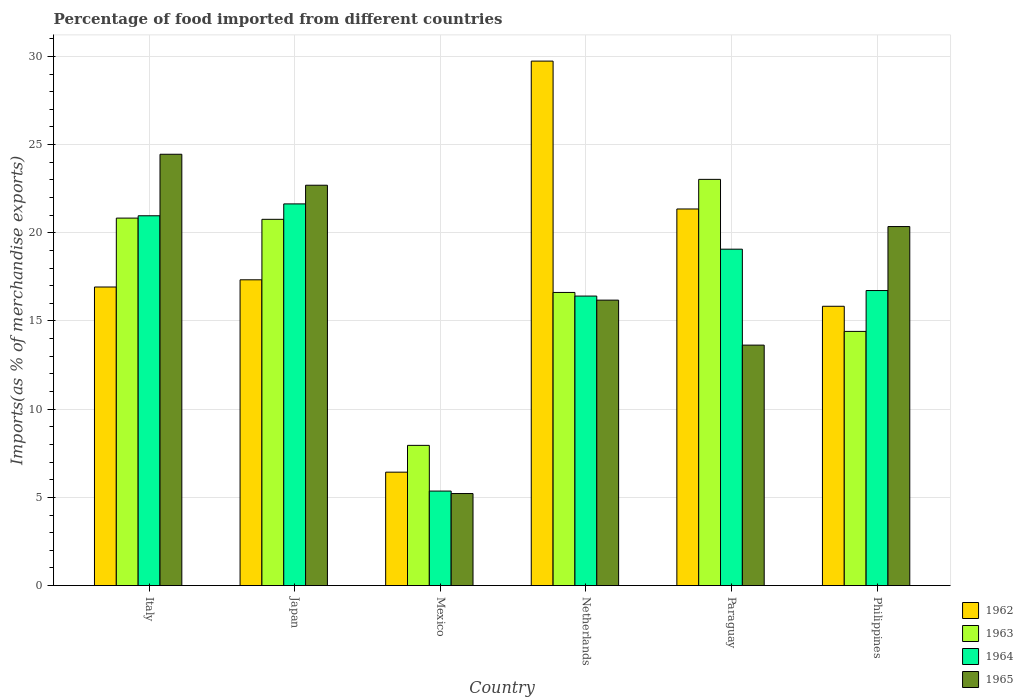How many different coloured bars are there?
Your answer should be very brief. 4. Are the number of bars per tick equal to the number of legend labels?
Make the answer very short. Yes. How many bars are there on the 6th tick from the right?
Keep it short and to the point. 4. What is the percentage of imports to different countries in 1962 in Italy?
Your answer should be compact. 16.93. Across all countries, what is the maximum percentage of imports to different countries in 1962?
Give a very brief answer. 29.73. Across all countries, what is the minimum percentage of imports to different countries in 1965?
Your answer should be compact. 5.22. In which country was the percentage of imports to different countries in 1963 minimum?
Your answer should be very brief. Mexico. What is the total percentage of imports to different countries in 1963 in the graph?
Keep it short and to the point. 103.6. What is the difference between the percentage of imports to different countries in 1965 in Mexico and that in Paraguay?
Provide a short and direct response. -8.42. What is the difference between the percentage of imports to different countries in 1963 in Mexico and the percentage of imports to different countries in 1964 in Philippines?
Make the answer very short. -8.78. What is the average percentage of imports to different countries in 1963 per country?
Ensure brevity in your answer.  17.27. What is the difference between the percentage of imports to different countries of/in 1963 and percentage of imports to different countries of/in 1965 in Italy?
Offer a terse response. -3.62. In how many countries, is the percentage of imports to different countries in 1964 greater than 3 %?
Give a very brief answer. 6. What is the ratio of the percentage of imports to different countries in 1962 in Mexico to that in Philippines?
Keep it short and to the point. 0.41. Is the difference between the percentage of imports to different countries in 1963 in Japan and Mexico greater than the difference between the percentage of imports to different countries in 1965 in Japan and Mexico?
Your answer should be very brief. No. What is the difference between the highest and the second highest percentage of imports to different countries in 1964?
Your answer should be compact. -1.89. What is the difference between the highest and the lowest percentage of imports to different countries in 1963?
Make the answer very short. 15.08. Is it the case that in every country, the sum of the percentage of imports to different countries in 1965 and percentage of imports to different countries in 1962 is greater than the sum of percentage of imports to different countries in 1963 and percentage of imports to different countries in 1964?
Offer a very short reply. No. What does the 4th bar from the left in Italy represents?
Ensure brevity in your answer.  1965. What does the 1st bar from the right in Philippines represents?
Keep it short and to the point. 1965. How many bars are there?
Provide a short and direct response. 24. Are the values on the major ticks of Y-axis written in scientific E-notation?
Provide a short and direct response. No. Does the graph contain grids?
Offer a very short reply. Yes. Where does the legend appear in the graph?
Keep it short and to the point. Bottom right. How many legend labels are there?
Keep it short and to the point. 4. What is the title of the graph?
Make the answer very short. Percentage of food imported from different countries. What is the label or title of the Y-axis?
Your answer should be compact. Imports(as % of merchandise exports). What is the Imports(as % of merchandise exports) of 1962 in Italy?
Provide a short and direct response. 16.93. What is the Imports(as % of merchandise exports) in 1963 in Italy?
Ensure brevity in your answer.  20.83. What is the Imports(as % of merchandise exports) of 1964 in Italy?
Offer a very short reply. 20.97. What is the Imports(as % of merchandise exports) in 1965 in Italy?
Give a very brief answer. 24.45. What is the Imports(as % of merchandise exports) in 1962 in Japan?
Your response must be concise. 17.34. What is the Imports(as % of merchandise exports) in 1963 in Japan?
Offer a terse response. 20.76. What is the Imports(as % of merchandise exports) in 1964 in Japan?
Offer a terse response. 21.64. What is the Imports(as % of merchandise exports) of 1965 in Japan?
Provide a short and direct response. 22.7. What is the Imports(as % of merchandise exports) of 1962 in Mexico?
Offer a terse response. 6.43. What is the Imports(as % of merchandise exports) of 1963 in Mexico?
Make the answer very short. 7.95. What is the Imports(as % of merchandise exports) in 1964 in Mexico?
Ensure brevity in your answer.  5.36. What is the Imports(as % of merchandise exports) of 1965 in Mexico?
Your answer should be very brief. 5.22. What is the Imports(as % of merchandise exports) of 1962 in Netherlands?
Offer a very short reply. 29.73. What is the Imports(as % of merchandise exports) in 1963 in Netherlands?
Provide a short and direct response. 16.62. What is the Imports(as % of merchandise exports) of 1964 in Netherlands?
Your answer should be very brief. 16.41. What is the Imports(as % of merchandise exports) in 1965 in Netherlands?
Offer a very short reply. 16.18. What is the Imports(as % of merchandise exports) in 1962 in Paraguay?
Offer a very short reply. 21.35. What is the Imports(as % of merchandise exports) in 1963 in Paraguay?
Provide a short and direct response. 23.03. What is the Imports(as % of merchandise exports) in 1964 in Paraguay?
Give a very brief answer. 19.07. What is the Imports(as % of merchandise exports) in 1965 in Paraguay?
Offer a terse response. 13.63. What is the Imports(as % of merchandise exports) in 1962 in Philippines?
Your answer should be compact. 15.83. What is the Imports(as % of merchandise exports) in 1963 in Philippines?
Make the answer very short. 14.41. What is the Imports(as % of merchandise exports) in 1964 in Philippines?
Make the answer very short. 16.73. What is the Imports(as % of merchandise exports) in 1965 in Philippines?
Offer a terse response. 20.35. Across all countries, what is the maximum Imports(as % of merchandise exports) of 1962?
Your response must be concise. 29.73. Across all countries, what is the maximum Imports(as % of merchandise exports) in 1963?
Provide a short and direct response. 23.03. Across all countries, what is the maximum Imports(as % of merchandise exports) in 1964?
Make the answer very short. 21.64. Across all countries, what is the maximum Imports(as % of merchandise exports) in 1965?
Give a very brief answer. 24.45. Across all countries, what is the minimum Imports(as % of merchandise exports) of 1962?
Your response must be concise. 6.43. Across all countries, what is the minimum Imports(as % of merchandise exports) of 1963?
Your answer should be very brief. 7.95. Across all countries, what is the minimum Imports(as % of merchandise exports) in 1964?
Offer a very short reply. 5.36. Across all countries, what is the minimum Imports(as % of merchandise exports) of 1965?
Your response must be concise. 5.22. What is the total Imports(as % of merchandise exports) in 1962 in the graph?
Make the answer very short. 107.61. What is the total Imports(as % of merchandise exports) in 1963 in the graph?
Provide a short and direct response. 103.6. What is the total Imports(as % of merchandise exports) in 1964 in the graph?
Provide a succinct answer. 100.17. What is the total Imports(as % of merchandise exports) of 1965 in the graph?
Offer a very short reply. 102.53. What is the difference between the Imports(as % of merchandise exports) of 1962 in Italy and that in Japan?
Offer a terse response. -0.41. What is the difference between the Imports(as % of merchandise exports) of 1963 in Italy and that in Japan?
Keep it short and to the point. 0.07. What is the difference between the Imports(as % of merchandise exports) in 1964 in Italy and that in Japan?
Offer a terse response. -0.67. What is the difference between the Imports(as % of merchandise exports) in 1965 in Italy and that in Japan?
Give a very brief answer. 1.76. What is the difference between the Imports(as % of merchandise exports) of 1962 in Italy and that in Mexico?
Make the answer very short. 10.5. What is the difference between the Imports(as % of merchandise exports) of 1963 in Italy and that in Mexico?
Give a very brief answer. 12.88. What is the difference between the Imports(as % of merchandise exports) in 1964 in Italy and that in Mexico?
Offer a very short reply. 15.61. What is the difference between the Imports(as % of merchandise exports) in 1965 in Italy and that in Mexico?
Ensure brevity in your answer.  19.24. What is the difference between the Imports(as % of merchandise exports) of 1962 in Italy and that in Netherlands?
Your answer should be compact. -12.81. What is the difference between the Imports(as % of merchandise exports) of 1963 in Italy and that in Netherlands?
Offer a terse response. 4.21. What is the difference between the Imports(as % of merchandise exports) of 1964 in Italy and that in Netherlands?
Your response must be concise. 4.55. What is the difference between the Imports(as % of merchandise exports) in 1965 in Italy and that in Netherlands?
Keep it short and to the point. 8.27. What is the difference between the Imports(as % of merchandise exports) of 1962 in Italy and that in Paraguay?
Provide a succinct answer. -4.42. What is the difference between the Imports(as % of merchandise exports) in 1963 in Italy and that in Paraguay?
Your response must be concise. -2.2. What is the difference between the Imports(as % of merchandise exports) of 1964 in Italy and that in Paraguay?
Offer a very short reply. 1.89. What is the difference between the Imports(as % of merchandise exports) in 1965 in Italy and that in Paraguay?
Your answer should be compact. 10.82. What is the difference between the Imports(as % of merchandise exports) in 1962 in Italy and that in Philippines?
Offer a very short reply. 1.09. What is the difference between the Imports(as % of merchandise exports) in 1963 in Italy and that in Philippines?
Provide a succinct answer. 6.42. What is the difference between the Imports(as % of merchandise exports) in 1964 in Italy and that in Philippines?
Make the answer very short. 4.24. What is the difference between the Imports(as % of merchandise exports) in 1965 in Italy and that in Philippines?
Keep it short and to the point. 4.1. What is the difference between the Imports(as % of merchandise exports) of 1962 in Japan and that in Mexico?
Make the answer very short. 10.91. What is the difference between the Imports(as % of merchandise exports) in 1963 in Japan and that in Mexico?
Offer a terse response. 12.82. What is the difference between the Imports(as % of merchandise exports) in 1964 in Japan and that in Mexico?
Make the answer very short. 16.28. What is the difference between the Imports(as % of merchandise exports) in 1965 in Japan and that in Mexico?
Make the answer very short. 17.48. What is the difference between the Imports(as % of merchandise exports) of 1962 in Japan and that in Netherlands?
Provide a short and direct response. -12.4. What is the difference between the Imports(as % of merchandise exports) of 1963 in Japan and that in Netherlands?
Your response must be concise. 4.15. What is the difference between the Imports(as % of merchandise exports) in 1964 in Japan and that in Netherlands?
Keep it short and to the point. 5.23. What is the difference between the Imports(as % of merchandise exports) of 1965 in Japan and that in Netherlands?
Your answer should be very brief. 6.51. What is the difference between the Imports(as % of merchandise exports) of 1962 in Japan and that in Paraguay?
Your answer should be compact. -4.02. What is the difference between the Imports(as % of merchandise exports) of 1963 in Japan and that in Paraguay?
Ensure brevity in your answer.  -2.26. What is the difference between the Imports(as % of merchandise exports) in 1964 in Japan and that in Paraguay?
Your answer should be compact. 2.57. What is the difference between the Imports(as % of merchandise exports) in 1965 in Japan and that in Paraguay?
Keep it short and to the point. 9.06. What is the difference between the Imports(as % of merchandise exports) in 1962 in Japan and that in Philippines?
Provide a short and direct response. 1.5. What is the difference between the Imports(as % of merchandise exports) of 1963 in Japan and that in Philippines?
Offer a terse response. 6.35. What is the difference between the Imports(as % of merchandise exports) in 1964 in Japan and that in Philippines?
Make the answer very short. 4.91. What is the difference between the Imports(as % of merchandise exports) of 1965 in Japan and that in Philippines?
Offer a terse response. 2.34. What is the difference between the Imports(as % of merchandise exports) in 1962 in Mexico and that in Netherlands?
Ensure brevity in your answer.  -23.31. What is the difference between the Imports(as % of merchandise exports) in 1963 in Mexico and that in Netherlands?
Provide a succinct answer. -8.67. What is the difference between the Imports(as % of merchandise exports) in 1964 in Mexico and that in Netherlands?
Your response must be concise. -11.05. What is the difference between the Imports(as % of merchandise exports) in 1965 in Mexico and that in Netherlands?
Your response must be concise. -10.97. What is the difference between the Imports(as % of merchandise exports) of 1962 in Mexico and that in Paraguay?
Your answer should be compact. -14.92. What is the difference between the Imports(as % of merchandise exports) of 1963 in Mexico and that in Paraguay?
Offer a very short reply. -15.08. What is the difference between the Imports(as % of merchandise exports) in 1964 in Mexico and that in Paraguay?
Keep it short and to the point. -13.71. What is the difference between the Imports(as % of merchandise exports) of 1965 in Mexico and that in Paraguay?
Your answer should be very brief. -8.42. What is the difference between the Imports(as % of merchandise exports) in 1962 in Mexico and that in Philippines?
Your response must be concise. -9.41. What is the difference between the Imports(as % of merchandise exports) in 1963 in Mexico and that in Philippines?
Offer a very short reply. -6.46. What is the difference between the Imports(as % of merchandise exports) of 1964 in Mexico and that in Philippines?
Provide a short and direct response. -11.37. What is the difference between the Imports(as % of merchandise exports) in 1965 in Mexico and that in Philippines?
Your answer should be compact. -15.14. What is the difference between the Imports(as % of merchandise exports) of 1962 in Netherlands and that in Paraguay?
Offer a very short reply. 8.38. What is the difference between the Imports(as % of merchandise exports) in 1963 in Netherlands and that in Paraguay?
Your response must be concise. -6.41. What is the difference between the Imports(as % of merchandise exports) of 1964 in Netherlands and that in Paraguay?
Offer a terse response. -2.66. What is the difference between the Imports(as % of merchandise exports) in 1965 in Netherlands and that in Paraguay?
Ensure brevity in your answer.  2.55. What is the difference between the Imports(as % of merchandise exports) of 1962 in Netherlands and that in Philippines?
Keep it short and to the point. 13.9. What is the difference between the Imports(as % of merchandise exports) in 1963 in Netherlands and that in Philippines?
Provide a succinct answer. 2.21. What is the difference between the Imports(as % of merchandise exports) in 1964 in Netherlands and that in Philippines?
Provide a short and direct response. -0.31. What is the difference between the Imports(as % of merchandise exports) of 1965 in Netherlands and that in Philippines?
Make the answer very short. -4.17. What is the difference between the Imports(as % of merchandise exports) in 1962 in Paraguay and that in Philippines?
Ensure brevity in your answer.  5.52. What is the difference between the Imports(as % of merchandise exports) of 1963 in Paraguay and that in Philippines?
Give a very brief answer. 8.62. What is the difference between the Imports(as % of merchandise exports) of 1964 in Paraguay and that in Philippines?
Make the answer very short. 2.35. What is the difference between the Imports(as % of merchandise exports) of 1965 in Paraguay and that in Philippines?
Offer a terse response. -6.72. What is the difference between the Imports(as % of merchandise exports) in 1962 in Italy and the Imports(as % of merchandise exports) in 1963 in Japan?
Your answer should be compact. -3.84. What is the difference between the Imports(as % of merchandise exports) of 1962 in Italy and the Imports(as % of merchandise exports) of 1964 in Japan?
Offer a very short reply. -4.71. What is the difference between the Imports(as % of merchandise exports) in 1962 in Italy and the Imports(as % of merchandise exports) in 1965 in Japan?
Keep it short and to the point. -5.77. What is the difference between the Imports(as % of merchandise exports) in 1963 in Italy and the Imports(as % of merchandise exports) in 1964 in Japan?
Offer a terse response. -0.81. What is the difference between the Imports(as % of merchandise exports) in 1963 in Italy and the Imports(as % of merchandise exports) in 1965 in Japan?
Make the answer very short. -1.86. What is the difference between the Imports(as % of merchandise exports) in 1964 in Italy and the Imports(as % of merchandise exports) in 1965 in Japan?
Give a very brief answer. -1.73. What is the difference between the Imports(as % of merchandise exports) of 1962 in Italy and the Imports(as % of merchandise exports) of 1963 in Mexico?
Provide a succinct answer. 8.98. What is the difference between the Imports(as % of merchandise exports) of 1962 in Italy and the Imports(as % of merchandise exports) of 1964 in Mexico?
Your answer should be very brief. 11.57. What is the difference between the Imports(as % of merchandise exports) of 1962 in Italy and the Imports(as % of merchandise exports) of 1965 in Mexico?
Offer a very short reply. 11.71. What is the difference between the Imports(as % of merchandise exports) of 1963 in Italy and the Imports(as % of merchandise exports) of 1964 in Mexico?
Your answer should be very brief. 15.48. What is the difference between the Imports(as % of merchandise exports) in 1963 in Italy and the Imports(as % of merchandise exports) in 1965 in Mexico?
Your response must be concise. 15.62. What is the difference between the Imports(as % of merchandise exports) of 1964 in Italy and the Imports(as % of merchandise exports) of 1965 in Mexico?
Ensure brevity in your answer.  15.75. What is the difference between the Imports(as % of merchandise exports) of 1962 in Italy and the Imports(as % of merchandise exports) of 1963 in Netherlands?
Provide a succinct answer. 0.31. What is the difference between the Imports(as % of merchandise exports) in 1962 in Italy and the Imports(as % of merchandise exports) in 1964 in Netherlands?
Your answer should be compact. 0.51. What is the difference between the Imports(as % of merchandise exports) in 1962 in Italy and the Imports(as % of merchandise exports) in 1965 in Netherlands?
Offer a terse response. 0.74. What is the difference between the Imports(as % of merchandise exports) in 1963 in Italy and the Imports(as % of merchandise exports) in 1964 in Netherlands?
Offer a very short reply. 4.42. What is the difference between the Imports(as % of merchandise exports) of 1963 in Italy and the Imports(as % of merchandise exports) of 1965 in Netherlands?
Offer a very short reply. 4.65. What is the difference between the Imports(as % of merchandise exports) of 1964 in Italy and the Imports(as % of merchandise exports) of 1965 in Netherlands?
Provide a succinct answer. 4.78. What is the difference between the Imports(as % of merchandise exports) in 1962 in Italy and the Imports(as % of merchandise exports) in 1963 in Paraguay?
Provide a short and direct response. -6.1. What is the difference between the Imports(as % of merchandise exports) in 1962 in Italy and the Imports(as % of merchandise exports) in 1964 in Paraguay?
Offer a terse response. -2.14. What is the difference between the Imports(as % of merchandise exports) of 1962 in Italy and the Imports(as % of merchandise exports) of 1965 in Paraguay?
Provide a short and direct response. 3.29. What is the difference between the Imports(as % of merchandise exports) in 1963 in Italy and the Imports(as % of merchandise exports) in 1964 in Paraguay?
Ensure brevity in your answer.  1.76. What is the difference between the Imports(as % of merchandise exports) in 1963 in Italy and the Imports(as % of merchandise exports) in 1965 in Paraguay?
Your answer should be very brief. 7.2. What is the difference between the Imports(as % of merchandise exports) in 1964 in Italy and the Imports(as % of merchandise exports) in 1965 in Paraguay?
Your answer should be very brief. 7.33. What is the difference between the Imports(as % of merchandise exports) of 1962 in Italy and the Imports(as % of merchandise exports) of 1963 in Philippines?
Give a very brief answer. 2.52. What is the difference between the Imports(as % of merchandise exports) of 1962 in Italy and the Imports(as % of merchandise exports) of 1964 in Philippines?
Keep it short and to the point. 0.2. What is the difference between the Imports(as % of merchandise exports) of 1962 in Italy and the Imports(as % of merchandise exports) of 1965 in Philippines?
Make the answer very short. -3.43. What is the difference between the Imports(as % of merchandise exports) of 1963 in Italy and the Imports(as % of merchandise exports) of 1964 in Philippines?
Offer a terse response. 4.11. What is the difference between the Imports(as % of merchandise exports) of 1963 in Italy and the Imports(as % of merchandise exports) of 1965 in Philippines?
Your answer should be compact. 0.48. What is the difference between the Imports(as % of merchandise exports) in 1964 in Italy and the Imports(as % of merchandise exports) in 1965 in Philippines?
Ensure brevity in your answer.  0.61. What is the difference between the Imports(as % of merchandise exports) of 1962 in Japan and the Imports(as % of merchandise exports) of 1963 in Mexico?
Your answer should be compact. 9.39. What is the difference between the Imports(as % of merchandise exports) in 1962 in Japan and the Imports(as % of merchandise exports) in 1964 in Mexico?
Ensure brevity in your answer.  11.98. What is the difference between the Imports(as % of merchandise exports) of 1962 in Japan and the Imports(as % of merchandise exports) of 1965 in Mexico?
Ensure brevity in your answer.  12.12. What is the difference between the Imports(as % of merchandise exports) in 1963 in Japan and the Imports(as % of merchandise exports) in 1964 in Mexico?
Give a very brief answer. 15.41. What is the difference between the Imports(as % of merchandise exports) of 1963 in Japan and the Imports(as % of merchandise exports) of 1965 in Mexico?
Keep it short and to the point. 15.55. What is the difference between the Imports(as % of merchandise exports) of 1964 in Japan and the Imports(as % of merchandise exports) of 1965 in Mexico?
Provide a short and direct response. 16.42. What is the difference between the Imports(as % of merchandise exports) in 1962 in Japan and the Imports(as % of merchandise exports) in 1963 in Netherlands?
Your answer should be very brief. 0.72. What is the difference between the Imports(as % of merchandise exports) in 1962 in Japan and the Imports(as % of merchandise exports) in 1964 in Netherlands?
Your answer should be compact. 0.92. What is the difference between the Imports(as % of merchandise exports) of 1962 in Japan and the Imports(as % of merchandise exports) of 1965 in Netherlands?
Offer a terse response. 1.15. What is the difference between the Imports(as % of merchandise exports) in 1963 in Japan and the Imports(as % of merchandise exports) in 1964 in Netherlands?
Give a very brief answer. 4.35. What is the difference between the Imports(as % of merchandise exports) of 1963 in Japan and the Imports(as % of merchandise exports) of 1965 in Netherlands?
Offer a very short reply. 4.58. What is the difference between the Imports(as % of merchandise exports) of 1964 in Japan and the Imports(as % of merchandise exports) of 1965 in Netherlands?
Offer a terse response. 5.46. What is the difference between the Imports(as % of merchandise exports) in 1962 in Japan and the Imports(as % of merchandise exports) in 1963 in Paraguay?
Your answer should be compact. -5.69. What is the difference between the Imports(as % of merchandise exports) in 1962 in Japan and the Imports(as % of merchandise exports) in 1964 in Paraguay?
Keep it short and to the point. -1.74. What is the difference between the Imports(as % of merchandise exports) of 1962 in Japan and the Imports(as % of merchandise exports) of 1965 in Paraguay?
Give a very brief answer. 3.7. What is the difference between the Imports(as % of merchandise exports) of 1963 in Japan and the Imports(as % of merchandise exports) of 1964 in Paraguay?
Provide a succinct answer. 1.69. What is the difference between the Imports(as % of merchandise exports) of 1963 in Japan and the Imports(as % of merchandise exports) of 1965 in Paraguay?
Your answer should be compact. 7.13. What is the difference between the Imports(as % of merchandise exports) in 1964 in Japan and the Imports(as % of merchandise exports) in 1965 in Paraguay?
Keep it short and to the point. 8.01. What is the difference between the Imports(as % of merchandise exports) in 1962 in Japan and the Imports(as % of merchandise exports) in 1963 in Philippines?
Give a very brief answer. 2.93. What is the difference between the Imports(as % of merchandise exports) in 1962 in Japan and the Imports(as % of merchandise exports) in 1964 in Philippines?
Provide a short and direct response. 0.61. What is the difference between the Imports(as % of merchandise exports) of 1962 in Japan and the Imports(as % of merchandise exports) of 1965 in Philippines?
Ensure brevity in your answer.  -3.02. What is the difference between the Imports(as % of merchandise exports) in 1963 in Japan and the Imports(as % of merchandise exports) in 1964 in Philippines?
Your answer should be very brief. 4.04. What is the difference between the Imports(as % of merchandise exports) of 1963 in Japan and the Imports(as % of merchandise exports) of 1965 in Philippines?
Provide a succinct answer. 0.41. What is the difference between the Imports(as % of merchandise exports) in 1964 in Japan and the Imports(as % of merchandise exports) in 1965 in Philippines?
Keep it short and to the point. 1.28. What is the difference between the Imports(as % of merchandise exports) of 1962 in Mexico and the Imports(as % of merchandise exports) of 1963 in Netherlands?
Provide a short and direct response. -10.19. What is the difference between the Imports(as % of merchandise exports) of 1962 in Mexico and the Imports(as % of merchandise exports) of 1964 in Netherlands?
Ensure brevity in your answer.  -9.98. What is the difference between the Imports(as % of merchandise exports) in 1962 in Mexico and the Imports(as % of merchandise exports) in 1965 in Netherlands?
Your answer should be very brief. -9.75. What is the difference between the Imports(as % of merchandise exports) of 1963 in Mexico and the Imports(as % of merchandise exports) of 1964 in Netherlands?
Your response must be concise. -8.46. What is the difference between the Imports(as % of merchandise exports) of 1963 in Mexico and the Imports(as % of merchandise exports) of 1965 in Netherlands?
Your answer should be compact. -8.23. What is the difference between the Imports(as % of merchandise exports) in 1964 in Mexico and the Imports(as % of merchandise exports) in 1965 in Netherlands?
Provide a short and direct response. -10.83. What is the difference between the Imports(as % of merchandise exports) in 1962 in Mexico and the Imports(as % of merchandise exports) in 1963 in Paraguay?
Provide a short and direct response. -16.6. What is the difference between the Imports(as % of merchandise exports) in 1962 in Mexico and the Imports(as % of merchandise exports) in 1964 in Paraguay?
Your answer should be compact. -12.64. What is the difference between the Imports(as % of merchandise exports) in 1962 in Mexico and the Imports(as % of merchandise exports) in 1965 in Paraguay?
Your answer should be compact. -7.2. What is the difference between the Imports(as % of merchandise exports) in 1963 in Mexico and the Imports(as % of merchandise exports) in 1964 in Paraguay?
Offer a very short reply. -11.12. What is the difference between the Imports(as % of merchandise exports) in 1963 in Mexico and the Imports(as % of merchandise exports) in 1965 in Paraguay?
Offer a very short reply. -5.68. What is the difference between the Imports(as % of merchandise exports) in 1964 in Mexico and the Imports(as % of merchandise exports) in 1965 in Paraguay?
Make the answer very short. -8.27. What is the difference between the Imports(as % of merchandise exports) of 1962 in Mexico and the Imports(as % of merchandise exports) of 1963 in Philippines?
Provide a short and direct response. -7.98. What is the difference between the Imports(as % of merchandise exports) in 1962 in Mexico and the Imports(as % of merchandise exports) in 1964 in Philippines?
Make the answer very short. -10.3. What is the difference between the Imports(as % of merchandise exports) of 1962 in Mexico and the Imports(as % of merchandise exports) of 1965 in Philippines?
Make the answer very short. -13.93. What is the difference between the Imports(as % of merchandise exports) in 1963 in Mexico and the Imports(as % of merchandise exports) in 1964 in Philippines?
Make the answer very short. -8.78. What is the difference between the Imports(as % of merchandise exports) in 1963 in Mexico and the Imports(as % of merchandise exports) in 1965 in Philippines?
Keep it short and to the point. -12.41. What is the difference between the Imports(as % of merchandise exports) of 1964 in Mexico and the Imports(as % of merchandise exports) of 1965 in Philippines?
Offer a terse response. -15. What is the difference between the Imports(as % of merchandise exports) of 1962 in Netherlands and the Imports(as % of merchandise exports) of 1963 in Paraguay?
Provide a short and direct response. 6.71. What is the difference between the Imports(as % of merchandise exports) in 1962 in Netherlands and the Imports(as % of merchandise exports) in 1964 in Paraguay?
Your answer should be compact. 10.66. What is the difference between the Imports(as % of merchandise exports) of 1962 in Netherlands and the Imports(as % of merchandise exports) of 1965 in Paraguay?
Offer a terse response. 16.1. What is the difference between the Imports(as % of merchandise exports) of 1963 in Netherlands and the Imports(as % of merchandise exports) of 1964 in Paraguay?
Your answer should be compact. -2.45. What is the difference between the Imports(as % of merchandise exports) in 1963 in Netherlands and the Imports(as % of merchandise exports) in 1965 in Paraguay?
Make the answer very short. 2.99. What is the difference between the Imports(as % of merchandise exports) in 1964 in Netherlands and the Imports(as % of merchandise exports) in 1965 in Paraguay?
Make the answer very short. 2.78. What is the difference between the Imports(as % of merchandise exports) of 1962 in Netherlands and the Imports(as % of merchandise exports) of 1963 in Philippines?
Your answer should be very brief. 15.32. What is the difference between the Imports(as % of merchandise exports) of 1962 in Netherlands and the Imports(as % of merchandise exports) of 1964 in Philippines?
Your answer should be compact. 13.01. What is the difference between the Imports(as % of merchandise exports) in 1962 in Netherlands and the Imports(as % of merchandise exports) in 1965 in Philippines?
Give a very brief answer. 9.38. What is the difference between the Imports(as % of merchandise exports) of 1963 in Netherlands and the Imports(as % of merchandise exports) of 1964 in Philippines?
Your response must be concise. -0.11. What is the difference between the Imports(as % of merchandise exports) in 1963 in Netherlands and the Imports(as % of merchandise exports) in 1965 in Philippines?
Provide a short and direct response. -3.74. What is the difference between the Imports(as % of merchandise exports) in 1964 in Netherlands and the Imports(as % of merchandise exports) in 1965 in Philippines?
Keep it short and to the point. -3.94. What is the difference between the Imports(as % of merchandise exports) of 1962 in Paraguay and the Imports(as % of merchandise exports) of 1963 in Philippines?
Make the answer very short. 6.94. What is the difference between the Imports(as % of merchandise exports) of 1962 in Paraguay and the Imports(as % of merchandise exports) of 1964 in Philippines?
Give a very brief answer. 4.62. What is the difference between the Imports(as % of merchandise exports) of 1963 in Paraguay and the Imports(as % of merchandise exports) of 1964 in Philippines?
Provide a short and direct response. 6.3. What is the difference between the Imports(as % of merchandise exports) of 1963 in Paraguay and the Imports(as % of merchandise exports) of 1965 in Philippines?
Make the answer very short. 2.67. What is the difference between the Imports(as % of merchandise exports) in 1964 in Paraguay and the Imports(as % of merchandise exports) in 1965 in Philippines?
Offer a terse response. -1.28. What is the average Imports(as % of merchandise exports) of 1962 per country?
Give a very brief answer. 17.93. What is the average Imports(as % of merchandise exports) of 1963 per country?
Provide a short and direct response. 17.27. What is the average Imports(as % of merchandise exports) in 1964 per country?
Your answer should be very brief. 16.7. What is the average Imports(as % of merchandise exports) in 1965 per country?
Your answer should be compact. 17.09. What is the difference between the Imports(as % of merchandise exports) of 1962 and Imports(as % of merchandise exports) of 1963 in Italy?
Provide a short and direct response. -3.91. What is the difference between the Imports(as % of merchandise exports) of 1962 and Imports(as % of merchandise exports) of 1964 in Italy?
Ensure brevity in your answer.  -4.04. What is the difference between the Imports(as % of merchandise exports) in 1962 and Imports(as % of merchandise exports) in 1965 in Italy?
Offer a terse response. -7.53. What is the difference between the Imports(as % of merchandise exports) in 1963 and Imports(as % of merchandise exports) in 1964 in Italy?
Ensure brevity in your answer.  -0.13. What is the difference between the Imports(as % of merchandise exports) of 1963 and Imports(as % of merchandise exports) of 1965 in Italy?
Provide a short and direct response. -3.62. What is the difference between the Imports(as % of merchandise exports) in 1964 and Imports(as % of merchandise exports) in 1965 in Italy?
Your answer should be compact. -3.49. What is the difference between the Imports(as % of merchandise exports) in 1962 and Imports(as % of merchandise exports) in 1963 in Japan?
Offer a very short reply. -3.43. What is the difference between the Imports(as % of merchandise exports) of 1962 and Imports(as % of merchandise exports) of 1964 in Japan?
Provide a succinct answer. -4.3. What is the difference between the Imports(as % of merchandise exports) of 1962 and Imports(as % of merchandise exports) of 1965 in Japan?
Make the answer very short. -5.36. What is the difference between the Imports(as % of merchandise exports) in 1963 and Imports(as % of merchandise exports) in 1964 in Japan?
Your answer should be very brief. -0.87. What is the difference between the Imports(as % of merchandise exports) of 1963 and Imports(as % of merchandise exports) of 1965 in Japan?
Provide a succinct answer. -1.93. What is the difference between the Imports(as % of merchandise exports) of 1964 and Imports(as % of merchandise exports) of 1965 in Japan?
Your answer should be compact. -1.06. What is the difference between the Imports(as % of merchandise exports) in 1962 and Imports(as % of merchandise exports) in 1963 in Mexico?
Your answer should be very brief. -1.52. What is the difference between the Imports(as % of merchandise exports) of 1962 and Imports(as % of merchandise exports) of 1964 in Mexico?
Your answer should be very brief. 1.07. What is the difference between the Imports(as % of merchandise exports) of 1962 and Imports(as % of merchandise exports) of 1965 in Mexico?
Offer a very short reply. 1.21. What is the difference between the Imports(as % of merchandise exports) in 1963 and Imports(as % of merchandise exports) in 1964 in Mexico?
Ensure brevity in your answer.  2.59. What is the difference between the Imports(as % of merchandise exports) of 1963 and Imports(as % of merchandise exports) of 1965 in Mexico?
Your answer should be compact. 2.73. What is the difference between the Imports(as % of merchandise exports) of 1964 and Imports(as % of merchandise exports) of 1965 in Mexico?
Ensure brevity in your answer.  0.14. What is the difference between the Imports(as % of merchandise exports) in 1962 and Imports(as % of merchandise exports) in 1963 in Netherlands?
Offer a very short reply. 13.12. What is the difference between the Imports(as % of merchandise exports) in 1962 and Imports(as % of merchandise exports) in 1964 in Netherlands?
Your answer should be compact. 13.32. What is the difference between the Imports(as % of merchandise exports) in 1962 and Imports(as % of merchandise exports) in 1965 in Netherlands?
Ensure brevity in your answer.  13.55. What is the difference between the Imports(as % of merchandise exports) of 1963 and Imports(as % of merchandise exports) of 1964 in Netherlands?
Offer a terse response. 0.21. What is the difference between the Imports(as % of merchandise exports) in 1963 and Imports(as % of merchandise exports) in 1965 in Netherlands?
Give a very brief answer. 0.44. What is the difference between the Imports(as % of merchandise exports) of 1964 and Imports(as % of merchandise exports) of 1965 in Netherlands?
Keep it short and to the point. 0.23. What is the difference between the Imports(as % of merchandise exports) in 1962 and Imports(as % of merchandise exports) in 1963 in Paraguay?
Your answer should be compact. -1.68. What is the difference between the Imports(as % of merchandise exports) of 1962 and Imports(as % of merchandise exports) of 1964 in Paraguay?
Your response must be concise. 2.28. What is the difference between the Imports(as % of merchandise exports) in 1962 and Imports(as % of merchandise exports) in 1965 in Paraguay?
Offer a terse response. 7.72. What is the difference between the Imports(as % of merchandise exports) of 1963 and Imports(as % of merchandise exports) of 1964 in Paraguay?
Ensure brevity in your answer.  3.96. What is the difference between the Imports(as % of merchandise exports) in 1963 and Imports(as % of merchandise exports) in 1965 in Paraguay?
Ensure brevity in your answer.  9.4. What is the difference between the Imports(as % of merchandise exports) of 1964 and Imports(as % of merchandise exports) of 1965 in Paraguay?
Ensure brevity in your answer.  5.44. What is the difference between the Imports(as % of merchandise exports) in 1962 and Imports(as % of merchandise exports) in 1963 in Philippines?
Give a very brief answer. 1.43. What is the difference between the Imports(as % of merchandise exports) of 1962 and Imports(as % of merchandise exports) of 1964 in Philippines?
Your answer should be very brief. -0.89. What is the difference between the Imports(as % of merchandise exports) in 1962 and Imports(as % of merchandise exports) in 1965 in Philippines?
Offer a very short reply. -4.52. What is the difference between the Imports(as % of merchandise exports) of 1963 and Imports(as % of merchandise exports) of 1964 in Philippines?
Give a very brief answer. -2.32. What is the difference between the Imports(as % of merchandise exports) in 1963 and Imports(as % of merchandise exports) in 1965 in Philippines?
Give a very brief answer. -5.94. What is the difference between the Imports(as % of merchandise exports) of 1964 and Imports(as % of merchandise exports) of 1965 in Philippines?
Ensure brevity in your answer.  -3.63. What is the ratio of the Imports(as % of merchandise exports) of 1962 in Italy to that in Japan?
Your answer should be compact. 0.98. What is the ratio of the Imports(as % of merchandise exports) in 1963 in Italy to that in Japan?
Make the answer very short. 1. What is the ratio of the Imports(as % of merchandise exports) in 1964 in Italy to that in Japan?
Give a very brief answer. 0.97. What is the ratio of the Imports(as % of merchandise exports) of 1965 in Italy to that in Japan?
Keep it short and to the point. 1.08. What is the ratio of the Imports(as % of merchandise exports) in 1962 in Italy to that in Mexico?
Offer a terse response. 2.63. What is the ratio of the Imports(as % of merchandise exports) of 1963 in Italy to that in Mexico?
Give a very brief answer. 2.62. What is the ratio of the Imports(as % of merchandise exports) of 1964 in Italy to that in Mexico?
Keep it short and to the point. 3.91. What is the ratio of the Imports(as % of merchandise exports) of 1965 in Italy to that in Mexico?
Ensure brevity in your answer.  4.69. What is the ratio of the Imports(as % of merchandise exports) of 1962 in Italy to that in Netherlands?
Offer a very short reply. 0.57. What is the ratio of the Imports(as % of merchandise exports) in 1963 in Italy to that in Netherlands?
Ensure brevity in your answer.  1.25. What is the ratio of the Imports(as % of merchandise exports) in 1964 in Italy to that in Netherlands?
Offer a terse response. 1.28. What is the ratio of the Imports(as % of merchandise exports) in 1965 in Italy to that in Netherlands?
Keep it short and to the point. 1.51. What is the ratio of the Imports(as % of merchandise exports) in 1962 in Italy to that in Paraguay?
Keep it short and to the point. 0.79. What is the ratio of the Imports(as % of merchandise exports) of 1963 in Italy to that in Paraguay?
Keep it short and to the point. 0.9. What is the ratio of the Imports(as % of merchandise exports) in 1964 in Italy to that in Paraguay?
Keep it short and to the point. 1.1. What is the ratio of the Imports(as % of merchandise exports) in 1965 in Italy to that in Paraguay?
Provide a short and direct response. 1.79. What is the ratio of the Imports(as % of merchandise exports) of 1962 in Italy to that in Philippines?
Ensure brevity in your answer.  1.07. What is the ratio of the Imports(as % of merchandise exports) of 1963 in Italy to that in Philippines?
Give a very brief answer. 1.45. What is the ratio of the Imports(as % of merchandise exports) of 1964 in Italy to that in Philippines?
Ensure brevity in your answer.  1.25. What is the ratio of the Imports(as % of merchandise exports) in 1965 in Italy to that in Philippines?
Offer a terse response. 1.2. What is the ratio of the Imports(as % of merchandise exports) of 1962 in Japan to that in Mexico?
Offer a terse response. 2.7. What is the ratio of the Imports(as % of merchandise exports) of 1963 in Japan to that in Mexico?
Provide a short and direct response. 2.61. What is the ratio of the Imports(as % of merchandise exports) of 1964 in Japan to that in Mexico?
Your answer should be compact. 4.04. What is the ratio of the Imports(as % of merchandise exports) of 1965 in Japan to that in Mexico?
Provide a succinct answer. 4.35. What is the ratio of the Imports(as % of merchandise exports) in 1962 in Japan to that in Netherlands?
Provide a succinct answer. 0.58. What is the ratio of the Imports(as % of merchandise exports) in 1963 in Japan to that in Netherlands?
Your answer should be compact. 1.25. What is the ratio of the Imports(as % of merchandise exports) of 1964 in Japan to that in Netherlands?
Provide a short and direct response. 1.32. What is the ratio of the Imports(as % of merchandise exports) of 1965 in Japan to that in Netherlands?
Provide a succinct answer. 1.4. What is the ratio of the Imports(as % of merchandise exports) of 1962 in Japan to that in Paraguay?
Make the answer very short. 0.81. What is the ratio of the Imports(as % of merchandise exports) in 1963 in Japan to that in Paraguay?
Give a very brief answer. 0.9. What is the ratio of the Imports(as % of merchandise exports) of 1964 in Japan to that in Paraguay?
Provide a succinct answer. 1.13. What is the ratio of the Imports(as % of merchandise exports) in 1965 in Japan to that in Paraguay?
Provide a short and direct response. 1.67. What is the ratio of the Imports(as % of merchandise exports) in 1962 in Japan to that in Philippines?
Ensure brevity in your answer.  1.09. What is the ratio of the Imports(as % of merchandise exports) of 1963 in Japan to that in Philippines?
Offer a terse response. 1.44. What is the ratio of the Imports(as % of merchandise exports) in 1964 in Japan to that in Philippines?
Your answer should be compact. 1.29. What is the ratio of the Imports(as % of merchandise exports) of 1965 in Japan to that in Philippines?
Keep it short and to the point. 1.12. What is the ratio of the Imports(as % of merchandise exports) in 1962 in Mexico to that in Netherlands?
Offer a terse response. 0.22. What is the ratio of the Imports(as % of merchandise exports) in 1963 in Mexico to that in Netherlands?
Your response must be concise. 0.48. What is the ratio of the Imports(as % of merchandise exports) in 1964 in Mexico to that in Netherlands?
Your answer should be very brief. 0.33. What is the ratio of the Imports(as % of merchandise exports) of 1965 in Mexico to that in Netherlands?
Your answer should be compact. 0.32. What is the ratio of the Imports(as % of merchandise exports) of 1962 in Mexico to that in Paraguay?
Your answer should be compact. 0.3. What is the ratio of the Imports(as % of merchandise exports) of 1963 in Mexico to that in Paraguay?
Make the answer very short. 0.35. What is the ratio of the Imports(as % of merchandise exports) in 1964 in Mexico to that in Paraguay?
Make the answer very short. 0.28. What is the ratio of the Imports(as % of merchandise exports) in 1965 in Mexico to that in Paraguay?
Provide a succinct answer. 0.38. What is the ratio of the Imports(as % of merchandise exports) in 1962 in Mexico to that in Philippines?
Ensure brevity in your answer.  0.41. What is the ratio of the Imports(as % of merchandise exports) in 1963 in Mexico to that in Philippines?
Your answer should be compact. 0.55. What is the ratio of the Imports(as % of merchandise exports) in 1964 in Mexico to that in Philippines?
Your answer should be compact. 0.32. What is the ratio of the Imports(as % of merchandise exports) in 1965 in Mexico to that in Philippines?
Provide a short and direct response. 0.26. What is the ratio of the Imports(as % of merchandise exports) of 1962 in Netherlands to that in Paraguay?
Your answer should be compact. 1.39. What is the ratio of the Imports(as % of merchandise exports) of 1963 in Netherlands to that in Paraguay?
Provide a succinct answer. 0.72. What is the ratio of the Imports(as % of merchandise exports) of 1964 in Netherlands to that in Paraguay?
Offer a terse response. 0.86. What is the ratio of the Imports(as % of merchandise exports) in 1965 in Netherlands to that in Paraguay?
Your response must be concise. 1.19. What is the ratio of the Imports(as % of merchandise exports) of 1962 in Netherlands to that in Philippines?
Offer a terse response. 1.88. What is the ratio of the Imports(as % of merchandise exports) in 1963 in Netherlands to that in Philippines?
Offer a very short reply. 1.15. What is the ratio of the Imports(as % of merchandise exports) of 1964 in Netherlands to that in Philippines?
Your answer should be compact. 0.98. What is the ratio of the Imports(as % of merchandise exports) of 1965 in Netherlands to that in Philippines?
Your answer should be compact. 0.8. What is the ratio of the Imports(as % of merchandise exports) of 1962 in Paraguay to that in Philippines?
Provide a short and direct response. 1.35. What is the ratio of the Imports(as % of merchandise exports) of 1963 in Paraguay to that in Philippines?
Offer a terse response. 1.6. What is the ratio of the Imports(as % of merchandise exports) in 1964 in Paraguay to that in Philippines?
Give a very brief answer. 1.14. What is the ratio of the Imports(as % of merchandise exports) in 1965 in Paraguay to that in Philippines?
Provide a succinct answer. 0.67. What is the difference between the highest and the second highest Imports(as % of merchandise exports) of 1962?
Provide a short and direct response. 8.38. What is the difference between the highest and the second highest Imports(as % of merchandise exports) of 1963?
Offer a very short reply. 2.2. What is the difference between the highest and the second highest Imports(as % of merchandise exports) of 1964?
Make the answer very short. 0.67. What is the difference between the highest and the second highest Imports(as % of merchandise exports) in 1965?
Offer a very short reply. 1.76. What is the difference between the highest and the lowest Imports(as % of merchandise exports) in 1962?
Keep it short and to the point. 23.31. What is the difference between the highest and the lowest Imports(as % of merchandise exports) in 1963?
Make the answer very short. 15.08. What is the difference between the highest and the lowest Imports(as % of merchandise exports) in 1964?
Your response must be concise. 16.28. What is the difference between the highest and the lowest Imports(as % of merchandise exports) of 1965?
Provide a short and direct response. 19.24. 